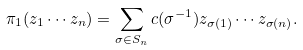<formula> <loc_0><loc_0><loc_500><loc_500>\pi _ { 1 } ( z _ { 1 } \cdots z _ { n } ) = \sum _ { \sigma \in S _ { n } } c ( \sigma ^ { - 1 } ) z _ { \sigma ( 1 ) } \cdots z _ { \sigma ( n ) } .</formula> 